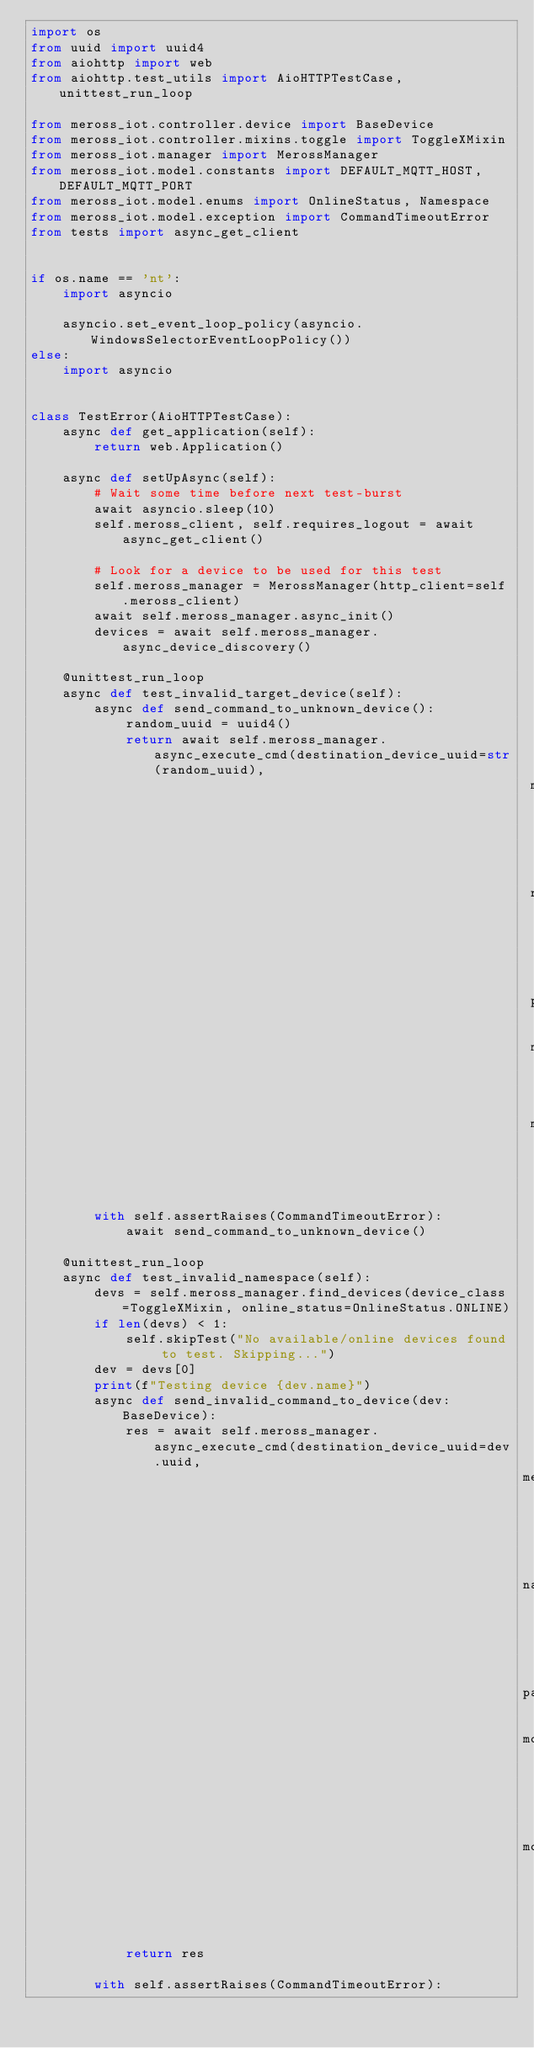<code> <loc_0><loc_0><loc_500><loc_500><_Python_>import os
from uuid import uuid4
from aiohttp import web
from aiohttp.test_utils import AioHTTPTestCase, unittest_run_loop

from meross_iot.controller.device import BaseDevice
from meross_iot.controller.mixins.toggle import ToggleXMixin
from meross_iot.manager import MerossManager
from meross_iot.model.constants import DEFAULT_MQTT_HOST, DEFAULT_MQTT_PORT
from meross_iot.model.enums import OnlineStatus, Namespace
from meross_iot.model.exception import CommandTimeoutError
from tests import async_get_client


if os.name == 'nt':
    import asyncio

    asyncio.set_event_loop_policy(asyncio.WindowsSelectorEventLoopPolicy())
else:
    import asyncio


class TestError(AioHTTPTestCase):
    async def get_application(self):
        return web.Application()

    async def setUpAsync(self):
        # Wait some time before next test-burst
        await asyncio.sleep(10)
        self.meross_client, self.requires_logout = await async_get_client()

        # Look for a device to be used for this test
        self.meross_manager = MerossManager(http_client=self.meross_client)
        await self.meross_manager.async_init()
        devices = await self.meross_manager.async_device_discovery()

    @unittest_run_loop
    async def test_invalid_target_device(self):
        async def send_command_to_unknown_device():
            random_uuid = uuid4()
            return await self.meross_manager.async_execute_cmd(destination_device_uuid=str(random_uuid),
                                                               method='GET',
                                                               namespace=Namespace.SYSTEM_ALL,
                                                               payload={},
                                                               mqtt_hostname=DEFAULT_MQTT_HOST,
                                                               mqtt_port=DEFAULT_MQTT_PORT)

        with self.assertRaises(CommandTimeoutError):
            await send_command_to_unknown_device()

    @unittest_run_loop
    async def test_invalid_namespace(self):
        devs = self.meross_manager.find_devices(device_class=ToggleXMixin, online_status=OnlineStatus.ONLINE)
        if len(devs) < 1:
            self.skipTest("No available/online devices found to test. Skipping...")
        dev = devs[0]
        print(f"Testing device {dev.name}")
        async def send_invalid_command_to_device(dev: BaseDevice):
            res = await self.meross_manager.async_execute_cmd(destination_device_uuid=dev.uuid,
                                                              method='GET',
                                                              namespace=Namespace.HUB_MTS100_MODE,
                                                              payload={},
                                                              mqtt_hostname=dev.mqtt_host,
                                                              mqtt_port=dev.mqtt_port)
            return res

        with self.assertRaises(CommandTimeoutError):</code> 